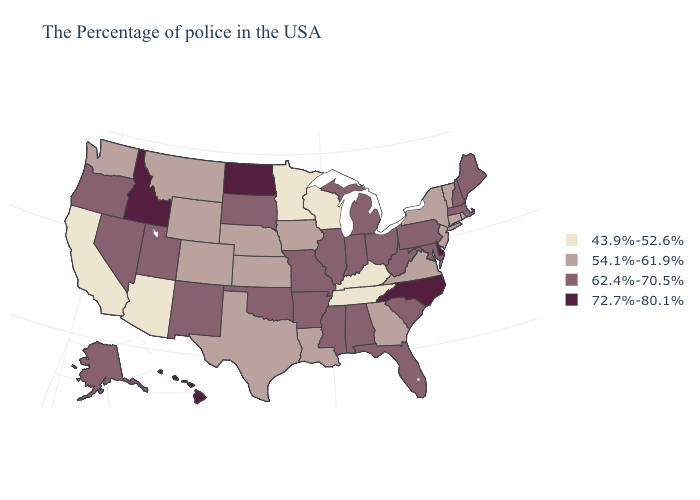Does the first symbol in the legend represent the smallest category?
Give a very brief answer. Yes. What is the value of Utah?
Write a very short answer. 62.4%-70.5%. Name the states that have a value in the range 62.4%-70.5%?
Answer briefly. Maine, Massachusetts, New Hampshire, Maryland, Pennsylvania, South Carolina, West Virginia, Ohio, Florida, Michigan, Indiana, Alabama, Illinois, Mississippi, Missouri, Arkansas, Oklahoma, South Dakota, New Mexico, Utah, Nevada, Oregon, Alaska. Name the states that have a value in the range 62.4%-70.5%?
Write a very short answer. Maine, Massachusetts, New Hampshire, Maryland, Pennsylvania, South Carolina, West Virginia, Ohio, Florida, Michigan, Indiana, Alabama, Illinois, Mississippi, Missouri, Arkansas, Oklahoma, South Dakota, New Mexico, Utah, Nevada, Oregon, Alaska. Does Kentucky have the lowest value in the USA?
Keep it brief. Yes. Which states hav the highest value in the Northeast?
Keep it brief. Maine, Massachusetts, New Hampshire, Pennsylvania. Is the legend a continuous bar?
Short answer required. No. Which states have the highest value in the USA?
Be succinct. Delaware, North Carolina, North Dakota, Idaho, Hawaii. Name the states that have a value in the range 54.1%-61.9%?
Be succinct. Rhode Island, Vermont, Connecticut, New York, New Jersey, Virginia, Georgia, Louisiana, Iowa, Kansas, Nebraska, Texas, Wyoming, Colorado, Montana, Washington. What is the value of Oklahoma?
Give a very brief answer. 62.4%-70.5%. Which states hav the highest value in the West?
Answer briefly. Idaho, Hawaii. Name the states that have a value in the range 54.1%-61.9%?
Quick response, please. Rhode Island, Vermont, Connecticut, New York, New Jersey, Virginia, Georgia, Louisiana, Iowa, Kansas, Nebraska, Texas, Wyoming, Colorado, Montana, Washington. Does Montana have a lower value than Connecticut?
Keep it brief. No. What is the highest value in states that border Georgia?
Give a very brief answer. 72.7%-80.1%. 